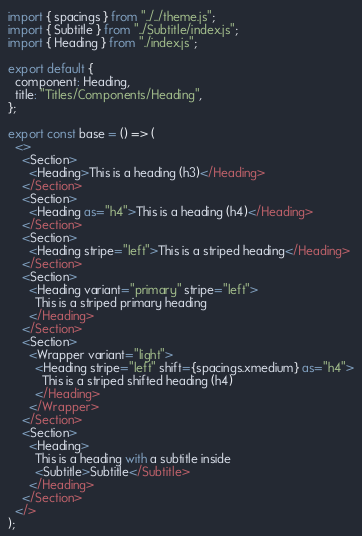Convert code to text. <code><loc_0><loc_0><loc_500><loc_500><_JavaScript_>import { spacings } from "../../theme.js";
import { Subtitle } from "../Subtitle/index.js";
import { Heading } from "./index.js";

export default {
  component: Heading,
  title: "Titles/Components/Heading",
};

export const base = () => (
  <>
    <Section>
      <Heading>This is a heading (h3)</Heading>
    </Section>
    <Section>
      <Heading as="h4">This is a heading (h4)</Heading>
    </Section>
    <Section>
      <Heading stripe="left">This is a striped heading</Heading>
    </Section>
    <Section>
      <Heading variant="primary" stripe="left">
        This is a striped primary heading
      </Heading>
    </Section>
    <Section>
      <Wrapper variant="light">
        <Heading stripe="left" shift={spacings.xmedium} as="h4">
          This is a striped shifted heading (h4)
        </Heading>
      </Wrapper>
    </Section>
    <Section>
      <Heading>
        This is a heading with a subtitle inside
        <Subtitle>Subtitle</Subtitle>
      </Heading>
    </Section>
  </>
);
</code> 